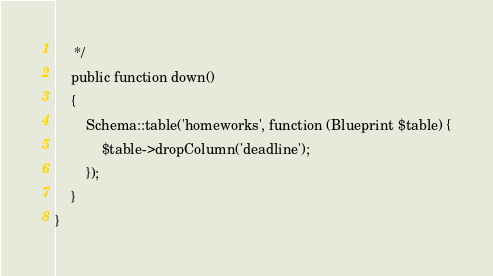Convert code to text. <code><loc_0><loc_0><loc_500><loc_500><_PHP_>     */
    public function down()
    {
        Schema::table('homeworks', function (Blueprint $table) {
            $table->dropColumn('deadline');
        });
    }
}
</code> 